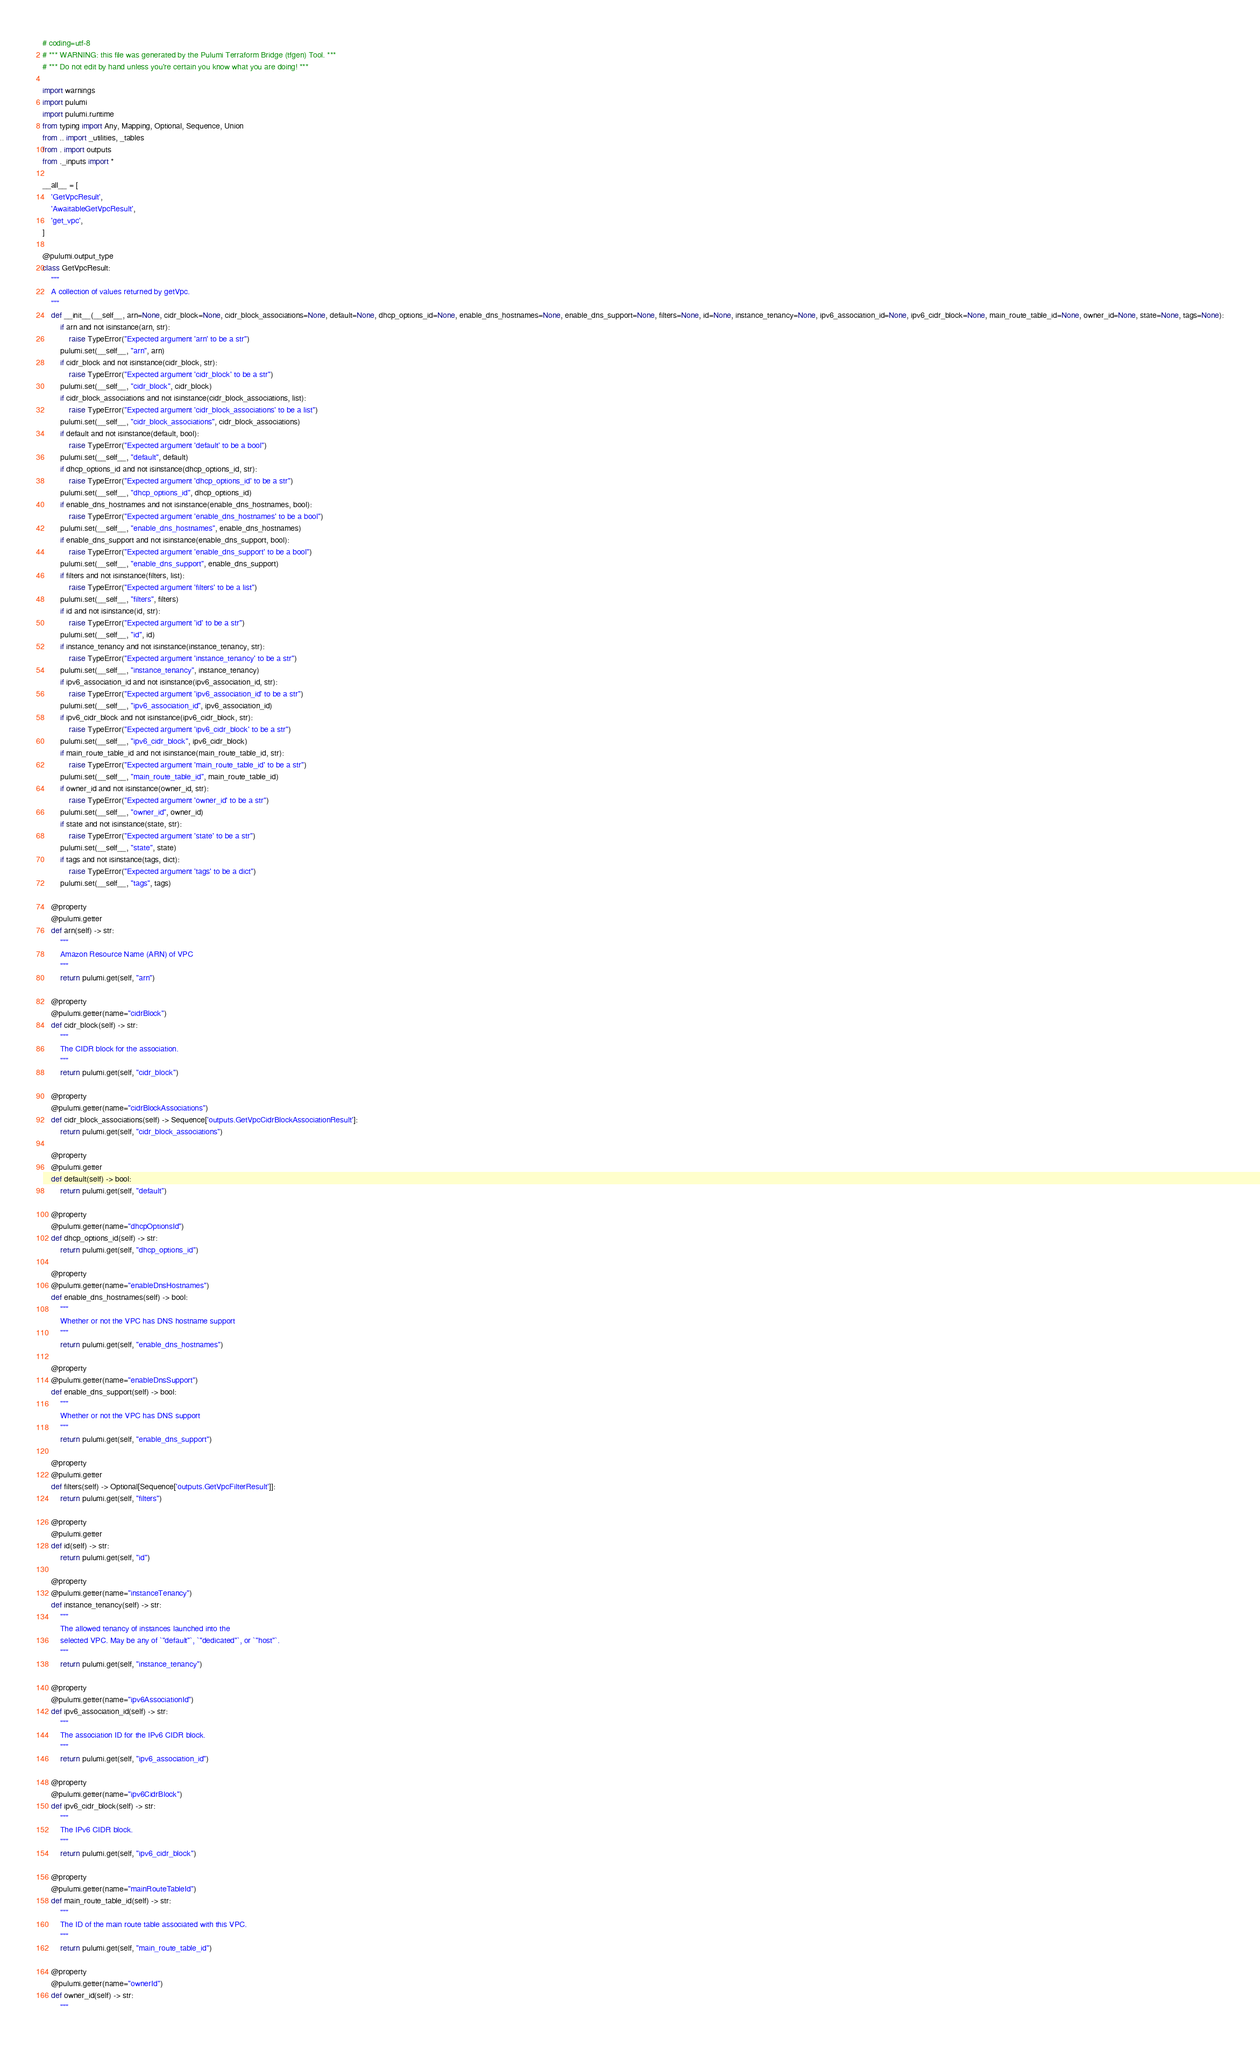<code> <loc_0><loc_0><loc_500><loc_500><_Python_># coding=utf-8
# *** WARNING: this file was generated by the Pulumi Terraform Bridge (tfgen) Tool. ***
# *** Do not edit by hand unless you're certain you know what you are doing! ***

import warnings
import pulumi
import pulumi.runtime
from typing import Any, Mapping, Optional, Sequence, Union
from .. import _utilities, _tables
from . import outputs
from ._inputs import *

__all__ = [
    'GetVpcResult',
    'AwaitableGetVpcResult',
    'get_vpc',
]

@pulumi.output_type
class GetVpcResult:
    """
    A collection of values returned by getVpc.
    """
    def __init__(__self__, arn=None, cidr_block=None, cidr_block_associations=None, default=None, dhcp_options_id=None, enable_dns_hostnames=None, enable_dns_support=None, filters=None, id=None, instance_tenancy=None, ipv6_association_id=None, ipv6_cidr_block=None, main_route_table_id=None, owner_id=None, state=None, tags=None):
        if arn and not isinstance(arn, str):
            raise TypeError("Expected argument 'arn' to be a str")
        pulumi.set(__self__, "arn", arn)
        if cidr_block and not isinstance(cidr_block, str):
            raise TypeError("Expected argument 'cidr_block' to be a str")
        pulumi.set(__self__, "cidr_block", cidr_block)
        if cidr_block_associations and not isinstance(cidr_block_associations, list):
            raise TypeError("Expected argument 'cidr_block_associations' to be a list")
        pulumi.set(__self__, "cidr_block_associations", cidr_block_associations)
        if default and not isinstance(default, bool):
            raise TypeError("Expected argument 'default' to be a bool")
        pulumi.set(__self__, "default", default)
        if dhcp_options_id and not isinstance(dhcp_options_id, str):
            raise TypeError("Expected argument 'dhcp_options_id' to be a str")
        pulumi.set(__self__, "dhcp_options_id", dhcp_options_id)
        if enable_dns_hostnames and not isinstance(enable_dns_hostnames, bool):
            raise TypeError("Expected argument 'enable_dns_hostnames' to be a bool")
        pulumi.set(__self__, "enable_dns_hostnames", enable_dns_hostnames)
        if enable_dns_support and not isinstance(enable_dns_support, bool):
            raise TypeError("Expected argument 'enable_dns_support' to be a bool")
        pulumi.set(__self__, "enable_dns_support", enable_dns_support)
        if filters and not isinstance(filters, list):
            raise TypeError("Expected argument 'filters' to be a list")
        pulumi.set(__self__, "filters", filters)
        if id and not isinstance(id, str):
            raise TypeError("Expected argument 'id' to be a str")
        pulumi.set(__self__, "id", id)
        if instance_tenancy and not isinstance(instance_tenancy, str):
            raise TypeError("Expected argument 'instance_tenancy' to be a str")
        pulumi.set(__self__, "instance_tenancy", instance_tenancy)
        if ipv6_association_id and not isinstance(ipv6_association_id, str):
            raise TypeError("Expected argument 'ipv6_association_id' to be a str")
        pulumi.set(__self__, "ipv6_association_id", ipv6_association_id)
        if ipv6_cidr_block and not isinstance(ipv6_cidr_block, str):
            raise TypeError("Expected argument 'ipv6_cidr_block' to be a str")
        pulumi.set(__self__, "ipv6_cidr_block", ipv6_cidr_block)
        if main_route_table_id and not isinstance(main_route_table_id, str):
            raise TypeError("Expected argument 'main_route_table_id' to be a str")
        pulumi.set(__self__, "main_route_table_id", main_route_table_id)
        if owner_id and not isinstance(owner_id, str):
            raise TypeError("Expected argument 'owner_id' to be a str")
        pulumi.set(__self__, "owner_id", owner_id)
        if state and not isinstance(state, str):
            raise TypeError("Expected argument 'state' to be a str")
        pulumi.set(__self__, "state", state)
        if tags and not isinstance(tags, dict):
            raise TypeError("Expected argument 'tags' to be a dict")
        pulumi.set(__self__, "tags", tags)

    @property
    @pulumi.getter
    def arn(self) -> str:
        """
        Amazon Resource Name (ARN) of VPC
        """
        return pulumi.get(self, "arn")

    @property
    @pulumi.getter(name="cidrBlock")
    def cidr_block(self) -> str:
        """
        The CIDR block for the association.
        """
        return pulumi.get(self, "cidr_block")

    @property
    @pulumi.getter(name="cidrBlockAssociations")
    def cidr_block_associations(self) -> Sequence['outputs.GetVpcCidrBlockAssociationResult']:
        return pulumi.get(self, "cidr_block_associations")

    @property
    @pulumi.getter
    def default(self) -> bool:
        return pulumi.get(self, "default")

    @property
    @pulumi.getter(name="dhcpOptionsId")
    def dhcp_options_id(self) -> str:
        return pulumi.get(self, "dhcp_options_id")

    @property
    @pulumi.getter(name="enableDnsHostnames")
    def enable_dns_hostnames(self) -> bool:
        """
        Whether or not the VPC has DNS hostname support
        """
        return pulumi.get(self, "enable_dns_hostnames")

    @property
    @pulumi.getter(name="enableDnsSupport")
    def enable_dns_support(self) -> bool:
        """
        Whether or not the VPC has DNS support
        """
        return pulumi.get(self, "enable_dns_support")

    @property
    @pulumi.getter
    def filters(self) -> Optional[Sequence['outputs.GetVpcFilterResult']]:
        return pulumi.get(self, "filters")

    @property
    @pulumi.getter
    def id(self) -> str:
        return pulumi.get(self, "id")

    @property
    @pulumi.getter(name="instanceTenancy")
    def instance_tenancy(self) -> str:
        """
        The allowed tenancy of instances launched into the
        selected VPC. May be any of `"default"`, `"dedicated"`, or `"host"`.
        """
        return pulumi.get(self, "instance_tenancy")

    @property
    @pulumi.getter(name="ipv6AssociationId")
    def ipv6_association_id(self) -> str:
        """
        The association ID for the IPv6 CIDR block.
        """
        return pulumi.get(self, "ipv6_association_id")

    @property
    @pulumi.getter(name="ipv6CidrBlock")
    def ipv6_cidr_block(self) -> str:
        """
        The IPv6 CIDR block.
        """
        return pulumi.get(self, "ipv6_cidr_block")

    @property
    @pulumi.getter(name="mainRouteTableId")
    def main_route_table_id(self) -> str:
        """
        The ID of the main route table associated with this VPC.
        """
        return pulumi.get(self, "main_route_table_id")

    @property
    @pulumi.getter(name="ownerId")
    def owner_id(self) -> str:
        """</code> 